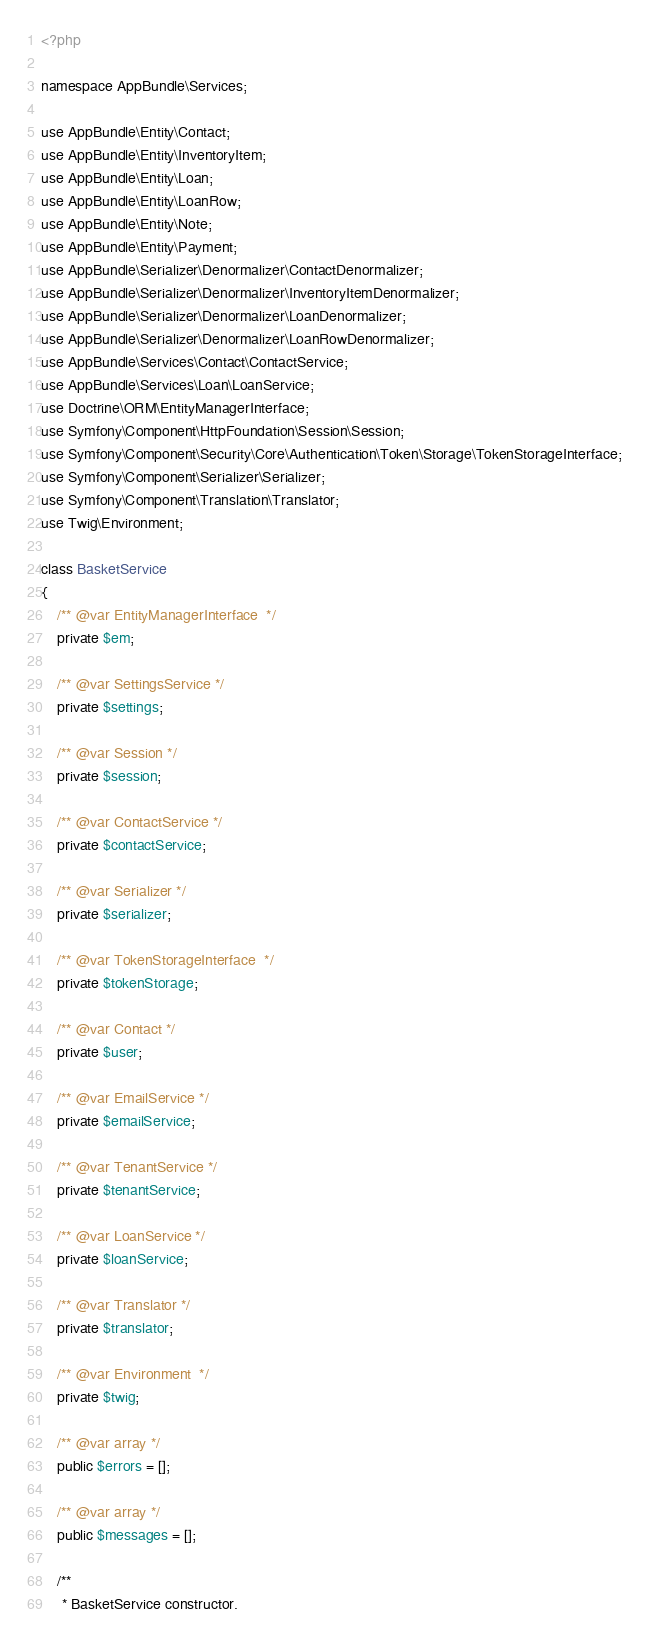<code> <loc_0><loc_0><loc_500><loc_500><_PHP_><?php

namespace AppBundle\Services;

use AppBundle\Entity\Contact;
use AppBundle\Entity\InventoryItem;
use AppBundle\Entity\Loan;
use AppBundle\Entity\LoanRow;
use AppBundle\Entity\Note;
use AppBundle\Entity\Payment;
use AppBundle\Serializer\Denormalizer\ContactDenormalizer;
use AppBundle\Serializer\Denormalizer\InventoryItemDenormalizer;
use AppBundle\Serializer\Denormalizer\LoanDenormalizer;
use AppBundle\Serializer\Denormalizer\LoanRowDenormalizer;
use AppBundle\Services\Contact\ContactService;
use AppBundle\Services\Loan\LoanService;
use Doctrine\ORM\EntityManagerInterface;
use Symfony\Component\HttpFoundation\Session\Session;
use Symfony\Component\Security\Core\Authentication\Token\Storage\TokenStorageInterface;
use Symfony\Component\Serializer\Serializer;
use Symfony\Component\Translation\Translator;
use Twig\Environment;

class BasketService
{
    /** @var EntityManagerInterface  */
    private $em;

    /** @var SettingsService */
    private $settings;

    /** @var Session */
    private $session;

    /** @var ContactService */
    private $contactService;

    /** @var Serializer */
    private $serializer;

    /** @var TokenStorageInterface  */
    private $tokenStorage;

    /** @var Contact */
    private $user;

    /** @var EmailService */
    private $emailService;

    /** @var TenantService */
    private $tenantService;

    /** @var LoanService */
    private $loanService;

    /** @var Translator */
    private $translator;

    /** @var Environment  */
    private $twig;

    /** @var array */
    public $errors = [];

    /** @var array */
    public $messages = [];

    /**
     * BasketService constructor.</code> 